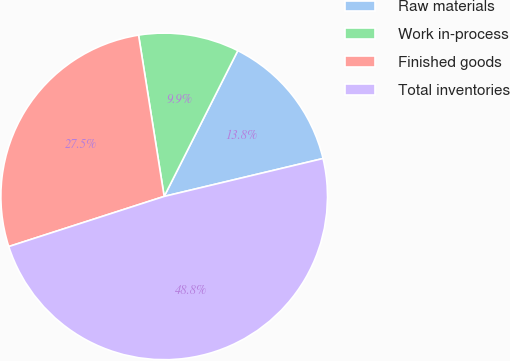<chart> <loc_0><loc_0><loc_500><loc_500><pie_chart><fcel>Raw materials<fcel>Work in-process<fcel>Finished goods<fcel>Total inventories<nl><fcel>13.83%<fcel>9.95%<fcel>27.46%<fcel>48.76%<nl></chart> 